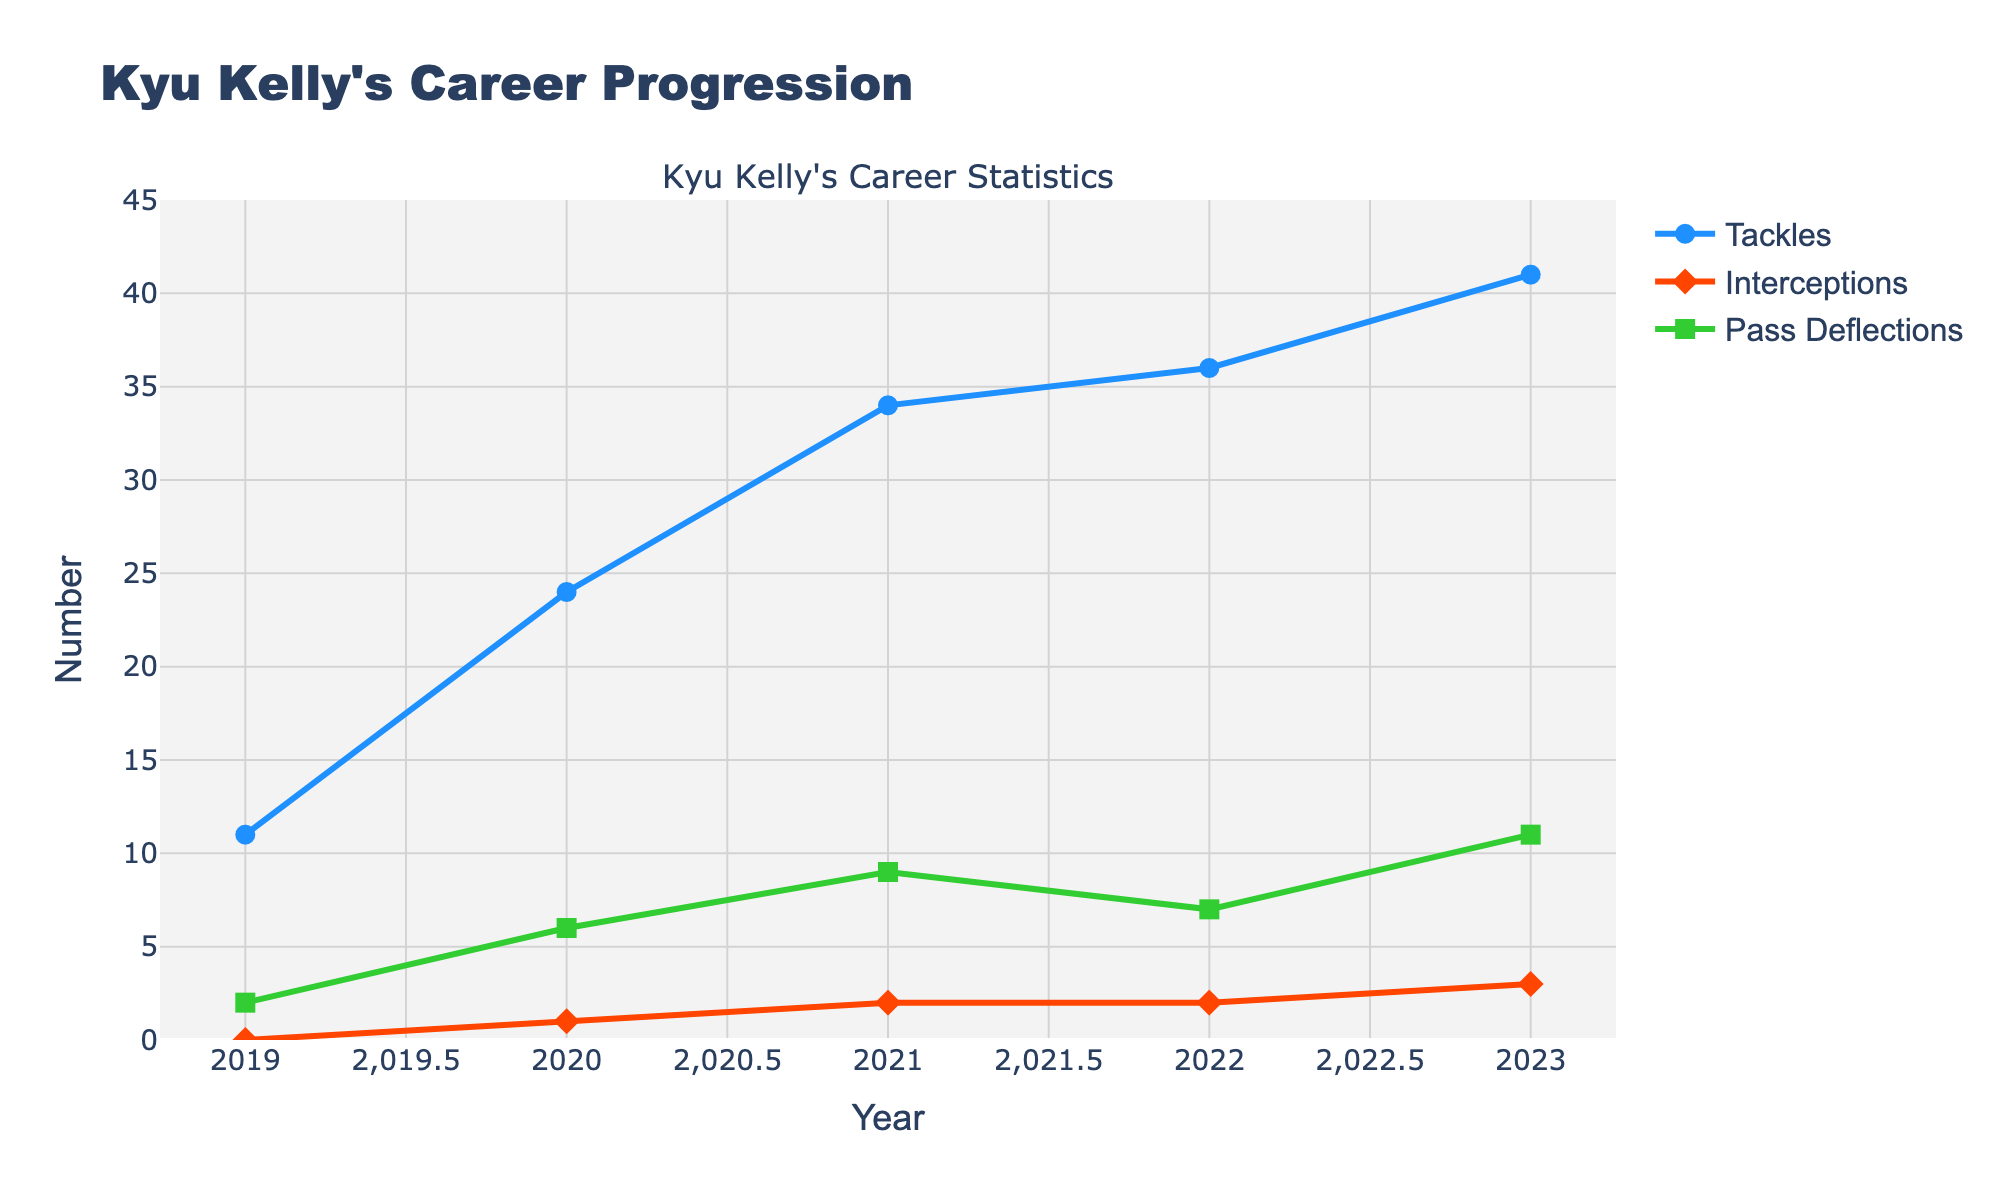What's the highest number of tackles Kyu Kelly made in a single year? The chart shows that the highest point for Tackles is in 2023, which is 41.
Answer: 41 In which year did Kyu Kelly achieve his highest number of interceptions, and how many were there? The peak for Interceptions is in 2023 with a value of 3.
Answer: 2023, 3 During which year did Kyu Kelly have the lowest number of pass deflections, and how many were there? The lowest point for Pass Deflections is in 2019, where he had 2 pass deflections.
Answer: 2019, 2 Compare the number of tackles between 2021 and 2023. How many more tackles did he make in 2023 compared to 2021? The number of tackles in 2021 is 34 and in 2023 is 41. The difference is 41 - 34 = 7.
Answer: 7 In which year did Kyu Kelly have the same number of interceptions and pass deflections, and what was that number? In 2021 and 2022, the intersections of the lines for Interceptions and Pass Deflections both occur at 2.
Answer: 2021 and 2022, 2 How did Kyu Kelly's tackles change from 2019 to 2023? Tackles increased from 11 in 2019 to 41 in 2023. The trend is consistently upward over the years.
Answer: Increased from 11 to 41 Calculate the average number of tackles over his college career. Sum the tackles over the years (11 + 24 + 34 + 36 + 41 = 146) and divide by the number of years (5). 146/5 = 29.2 tackles on average.
Answer: 29.2 What is the total number of interceptions Kyu Kelly made from 2019 to 2023? Sum the interceptions over the years (0 + 1 + 2 + 2 + 3 = 8).
Answer: 8 Compare the growth rate of pass deflections from 2019 to 2023 with that of interceptions. Which grew more? Pass deflections grew from 2 to 11 (a difference of 9), and interceptions grew from 0 to 3 (a difference of 3).
Answer: Pass deflections grew more What year shows the most significant overall improvement in Kyu Kelly's performance statistics? Examining the steepest increase for all lines, 2020 had a significant jump in Tackles, Interceptions, and Pass Deflections, indicating it as the most improved year.
Answer: 2020 